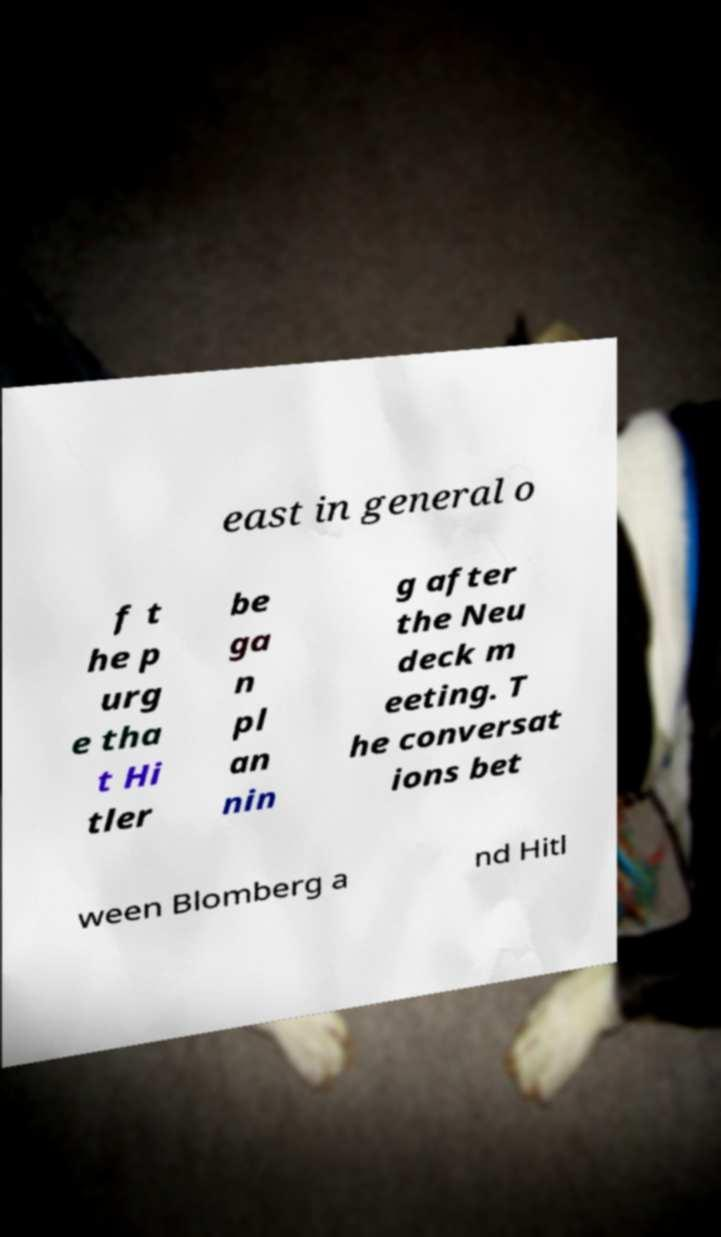For documentation purposes, I need the text within this image transcribed. Could you provide that? east in general o f t he p urg e tha t Hi tler be ga n pl an nin g after the Neu deck m eeting. T he conversat ions bet ween Blomberg a nd Hitl 